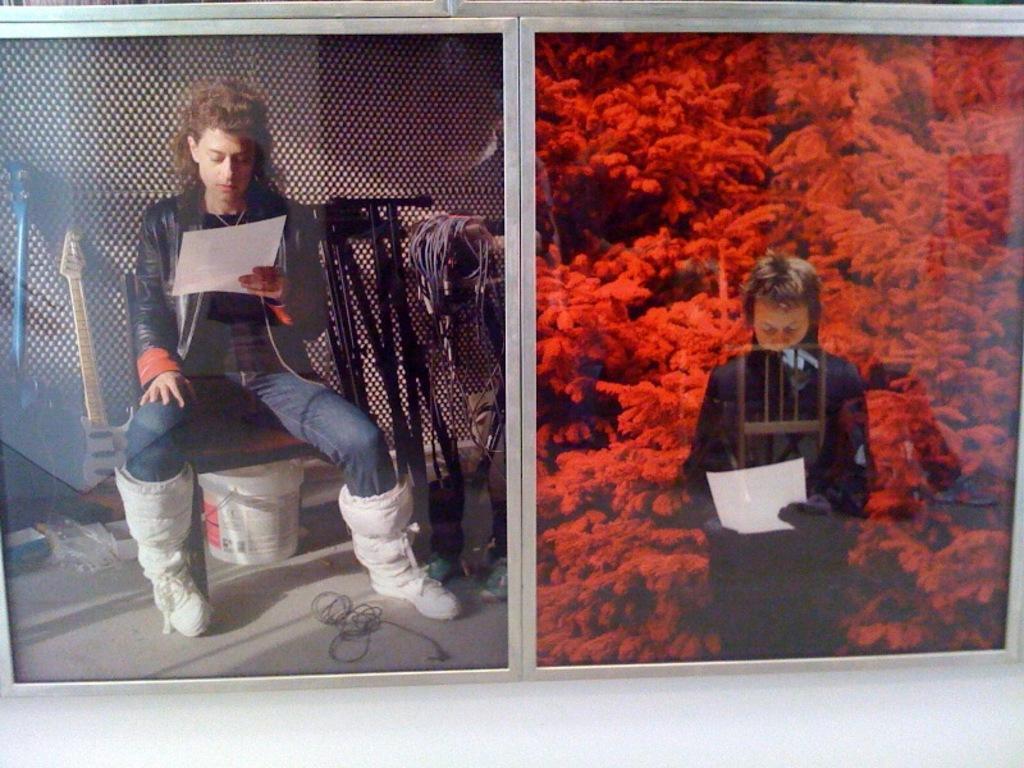How would you summarize this image in a sentence or two? A collage picture. This man is sitting on a chair and holding a paper. Here we can see musical instruments and bucket. In this picture, this man is holding a paper. Background it is in red color. 